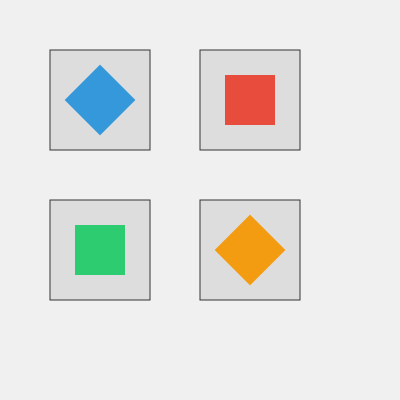In a responsive grid layout with four cells, SVG icons are positioned and rotated as shown. If the grid container's width is reduced by 25%, maintaining aspect ratio, what would be the new rotation angle (in degrees) of the bottom-right icon to maintain visual consistency? To solve this problem, we need to follow these steps:

1. Observe the current layout:
   - 2x2 grid with four cells
   - Each cell contains a rotated square icon
   - Bottom-right icon is currently rotated 135°

2. Understand the transformation:
   - Grid width is reduced by 25%
   - Aspect ratio is maintained, so height will also reduce by 25%

3. Analyze the impact on icon rotation:
   - Reducing dimensions doesn't affect rotation angles directly
   - To maintain visual consistency, we need to keep the same relative orientation

4. Calculate the new rotation angle:
   - Current angle: 135°
   - In a square grid, 45° increments create visually consistent rotations
   - 135° is 3 * 45°, which we want to maintain

5. Conclude:
   - Since the grid's aspect ratio is maintained and we want to keep visual consistency, the rotation angle of the bottom-right icon should remain the same: 135°

Therefore, the new rotation angle for the bottom-right icon would be 135°, unchanged from its original position.
Answer: 135° 